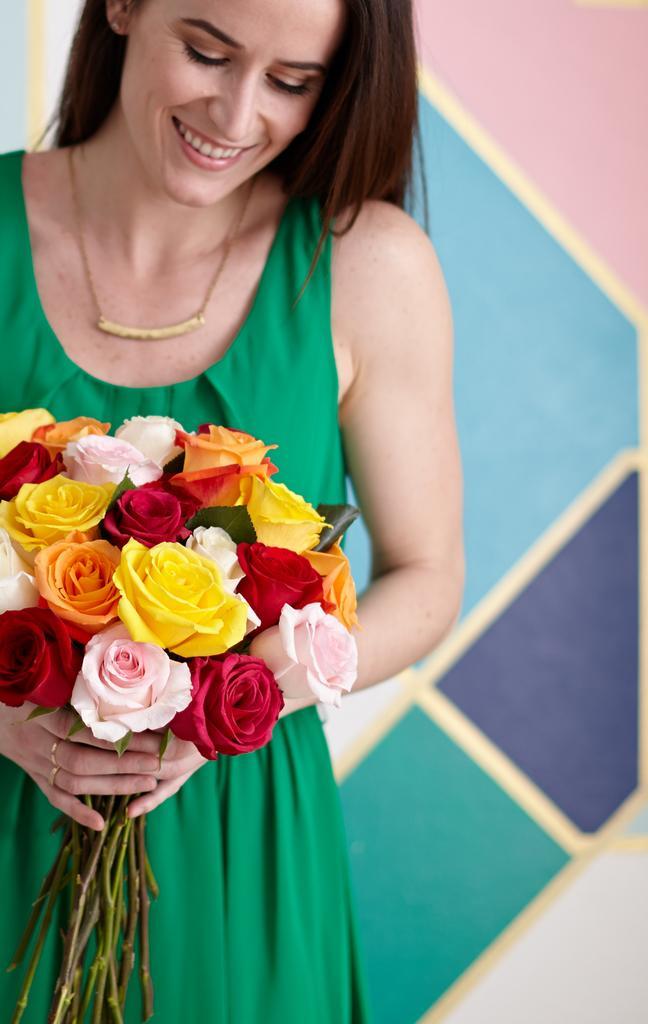Please provide a concise description of this image. In this picture we can see a woman holding a bouquet. Behind the woman, it looks like a wall. 